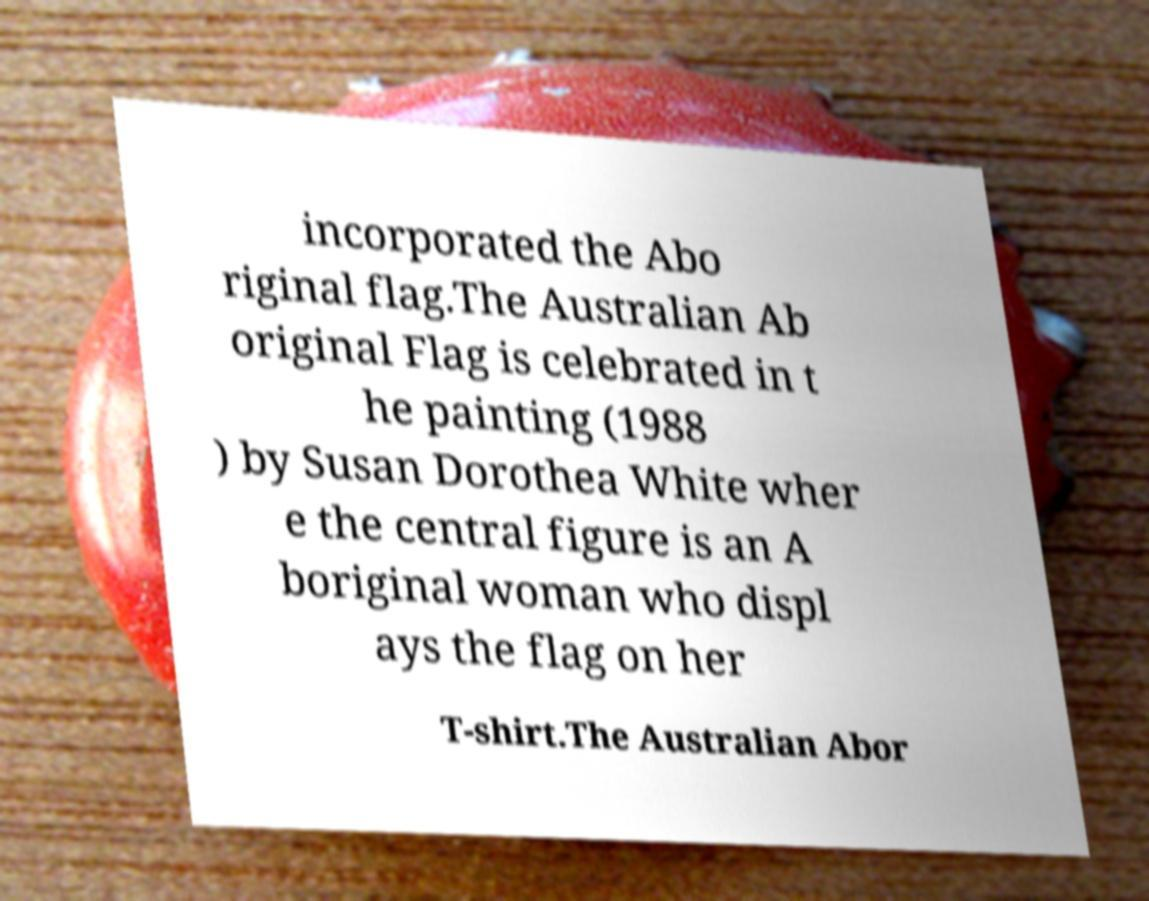Please identify and transcribe the text found in this image. incorporated the Abo riginal flag.The Australian Ab original Flag is celebrated in t he painting (1988 ) by Susan Dorothea White wher e the central figure is an A boriginal woman who displ ays the flag on her T-shirt.The Australian Abor 